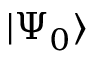<formula> <loc_0><loc_0><loc_500><loc_500>| \Psi _ { 0 } \rangle</formula> 